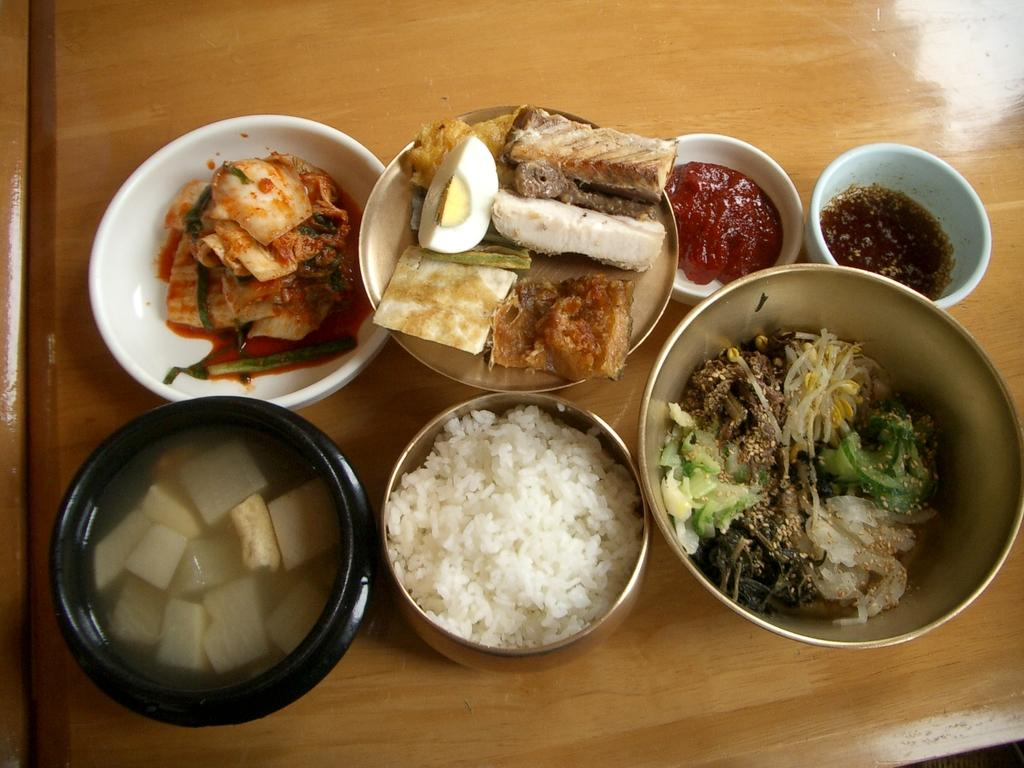What can be seen in the image in terms of food items? There are many food items in the image. How are the food items arranged in the image? The food items are in different bowls. Where are the bowls with food items located? The bowls are on a dining table. What type of peace symbol can be seen among the food items in the image? There is no peace symbol present among the food items in the image. What kind of structure is supporting the dining table in the image? The image does not show any structure supporting the dining table; it only shows the table with bowls on it. 